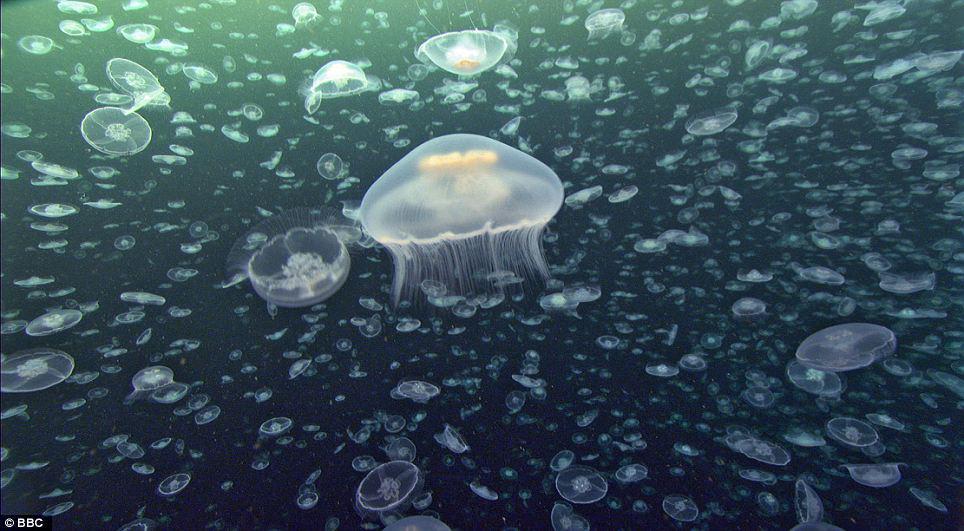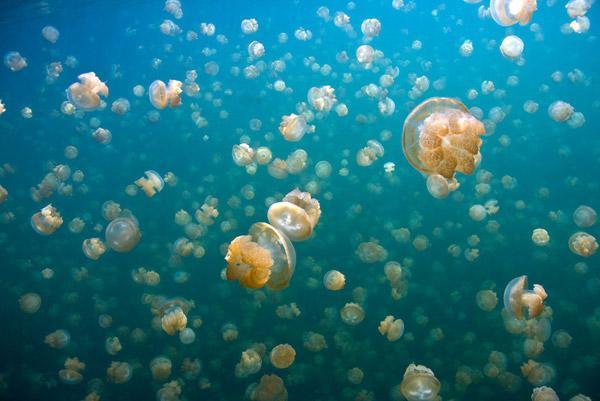The first image is the image on the left, the second image is the image on the right. Given the left and right images, does the statement "Left image shows a prominent jellyfish in foreground with many smaller jellyfish in the background." hold true? Answer yes or no. Yes. The first image is the image on the left, the second image is the image on the right. Examine the images to the left and right. Is the description "There is a single jellyfish in the image on the left" accurate? Answer yes or no. No. 